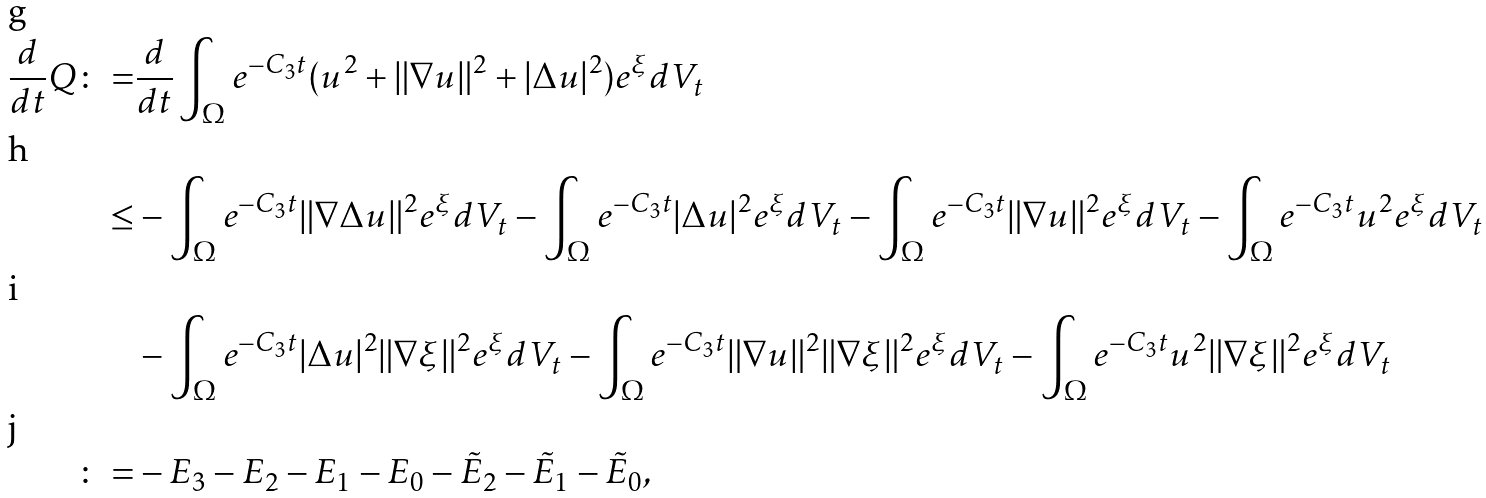Convert formula to latex. <formula><loc_0><loc_0><loc_500><loc_500>\frac { d } { d t } Q \colon = & \frac { d } { d t } \int _ { \Omega } e ^ { - C _ { 3 } t } ( u ^ { 2 } + \| \nabla u \| ^ { 2 } + | \Delta u | ^ { 2 } ) e ^ { \xi } d V _ { t } \\ \leq & - \int _ { \Omega } e ^ { - C _ { 3 } t } \| \nabla \Delta u \| ^ { 2 } e ^ { \xi } d V _ { t } - \int _ { \Omega } e ^ { - C _ { 3 } t } | \Delta u | ^ { 2 } e ^ { \xi } d V _ { t } - \int _ { \Omega } e ^ { - C _ { 3 } t } \| \nabla u \| ^ { 2 } e ^ { \xi } d V _ { t } - \int _ { \Omega } e ^ { - C _ { 3 } t } u ^ { 2 } e ^ { \xi } d V _ { t } \\ & - \int _ { \Omega } e ^ { - C _ { 3 } t } | \Delta u | ^ { 2 } \| \nabla \xi \| ^ { 2 } e ^ { \xi } d V _ { t } - \int _ { \Omega } e ^ { - C _ { 3 } t } \| \nabla u \| ^ { 2 } \| \nabla \xi \| ^ { 2 } e ^ { \xi } d V _ { t } - \int _ { \Omega } e ^ { - C _ { 3 } t } u ^ { 2 } \| \nabla \xi \| ^ { 2 } e ^ { \xi } d V _ { t } \\ \colon = & - E _ { 3 } - E _ { 2 } - E _ { 1 } - E _ { 0 } - \tilde { E } _ { 2 } - \tilde { E } _ { 1 } - \tilde { E } _ { 0 } ,</formula> 